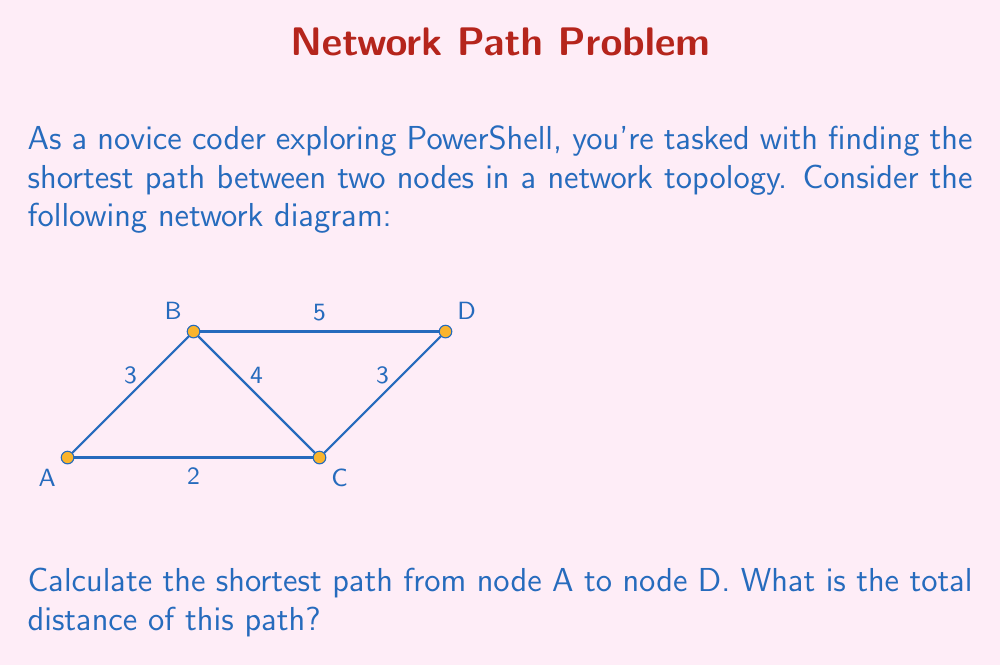Provide a solution to this math problem. To solve this problem, we can use Dijkstra's algorithm, which is commonly used to find the shortest path in a network. However, for this simple network, we can solve it by considering all possible paths:

1. Path A-B-D: $3 + 5 = 8$
2. Path A-C-D: $2 + 3 = 5$
3. Path A-B-C-D: $3 + 4 + 3 = 10$

To find the shortest path, we compare the total distances:

$$\min(8, 5, 10) = 5$$

The shortest path is A-C-D with a total distance of 5.

In PowerShell, you could represent this network as a hashtable and implement a simple path-finding algorithm. This problem demonstrates the importance of efficient algorithms in network analysis, which can be valuable when working with PowerShell for network management and automation tasks.
Answer: 5 